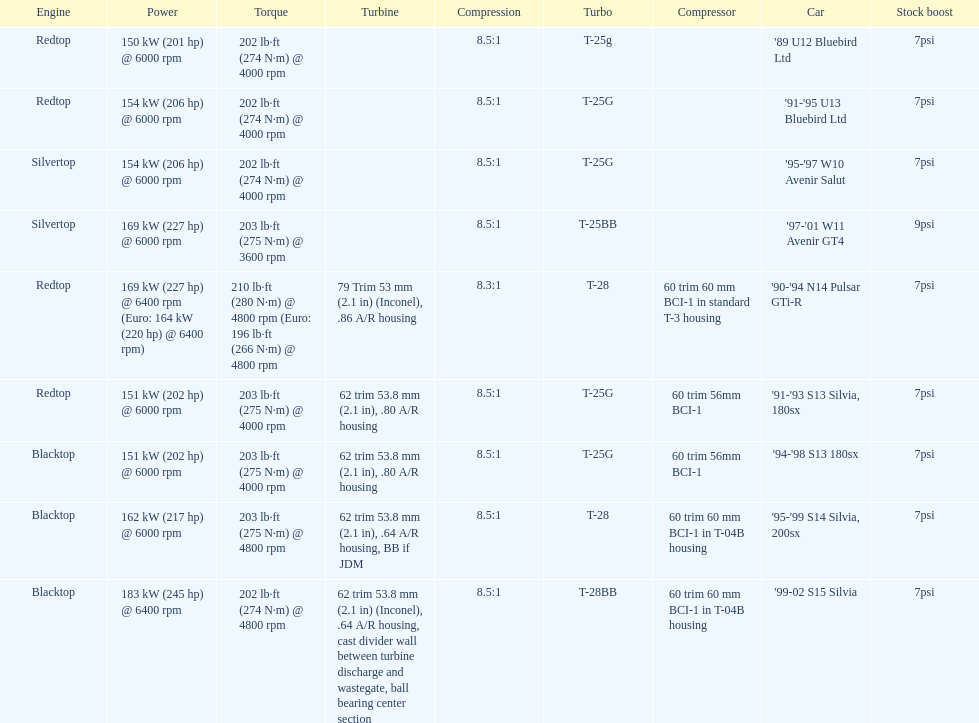Which engine has the least amount of compression ratio? '90-'94 N14 Pulsar GTi-R. 